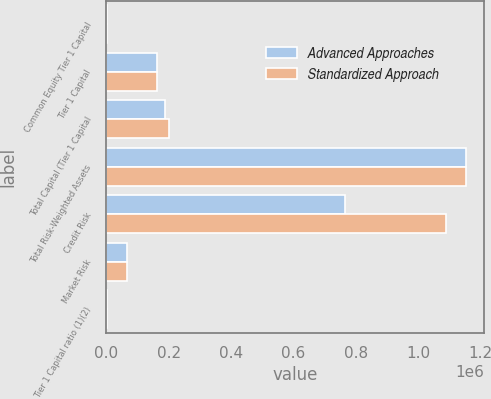Convert chart. <chart><loc_0><loc_0><loc_500><loc_500><stacked_bar_chart><ecel><fcel>Common Equity Tier 1 Capital<fcel>Tier 1 Capital<fcel>Total Capital (Tier 1 Capital<fcel>Total Risk-Weighted Assets<fcel>Credit Risk<fcel>Market Risk<fcel>Tier 1 Capital ratio (1)(2)<nl><fcel>Advanced Approaches<fcel>12.39<fcel>162377<fcel>187877<fcel>1.15264e+06<fcel>767102<fcel>65003<fcel>14.09<nl><fcel>Standardized Approach<fcel>12.36<fcel>162377<fcel>199989<fcel>1.1551e+06<fcel>1.08937e+06<fcel>65727<fcel>14.06<nl></chart> 